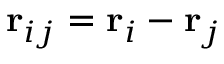Convert formula to latex. <formula><loc_0><loc_0><loc_500><loc_500>r _ { i j } = r _ { i } - r _ { j }</formula> 